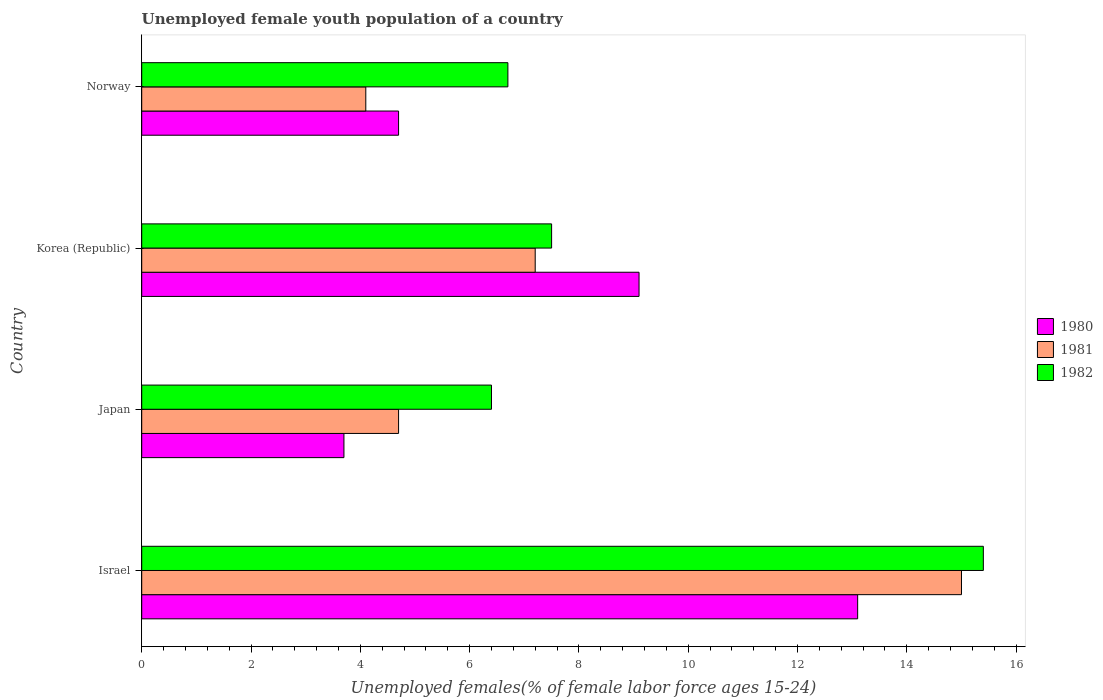How many different coloured bars are there?
Keep it short and to the point. 3. How many groups of bars are there?
Offer a very short reply. 4. Are the number of bars on each tick of the Y-axis equal?
Your answer should be very brief. Yes. How many bars are there on the 4th tick from the top?
Your answer should be very brief. 3. What is the label of the 4th group of bars from the top?
Give a very brief answer. Israel. What is the percentage of unemployed female youth population in 1981 in Israel?
Provide a succinct answer. 15. Across all countries, what is the maximum percentage of unemployed female youth population in 1982?
Your answer should be compact. 15.4. Across all countries, what is the minimum percentage of unemployed female youth population in 1981?
Give a very brief answer. 4.1. In which country was the percentage of unemployed female youth population in 1980 maximum?
Provide a succinct answer. Israel. What is the total percentage of unemployed female youth population in 1981 in the graph?
Your answer should be very brief. 31. What is the difference between the percentage of unemployed female youth population in 1981 in Korea (Republic) and that in Norway?
Offer a terse response. 3.1. What is the difference between the percentage of unemployed female youth population in 1982 in Israel and the percentage of unemployed female youth population in 1981 in Japan?
Your answer should be compact. 10.7. What is the average percentage of unemployed female youth population in 1982 per country?
Provide a succinct answer. 9. What is the difference between the percentage of unemployed female youth population in 1982 and percentage of unemployed female youth population in 1981 in Japan?
Ensure brevity in your answer.  1.7. In how many countries, is the percentage of unemployed female youth population in 1980 greater than 1.2000000000000002 %?
Provide a short and direct response. 4. What is the ratio of the percentage of unemployed female youth population in 1981 in Israel to that in Korea (Republic)?
Make the answer very short. 2.08. Is the percentage of unemployed female youth population in 1982 in Japan less than that in Korea (Republic)?
Provide a short and direct response. Yes. Is the difference between the percentage of unemployed female youth population in 1982 in Japan and Norway greater than the difference between the percentage of unemployed female youth population in 1981 in Japan and Norway?
Make the answer very short. No. What is the difference between the highest and the second highest percentage of unemployed female youth population in 1980?
Your answer should be very brief. 4. What is the difference between the highest and the lowest percentage of unemployed female youth population in 1981?
Provide a short and direct response. 10.9. In how many countries, is the percentage of unemployed female youth population in 1980 greater than the average percentage of unemployed female youth population in 1980 taken over all countries?
Ensure brevity in your answer.  2. Is the sum of the percentage of unemployed female youth population in 1982 in Israel and Korea (Republic) greater than the maximum percentage of unemployed female youth population in 1980 across all countries?
Your answer should be compact. Yes. Is it the case that in every country, the sum of the percentage of unemployed female youth population in 1980 and percentage of unemployed female youth population in 1982 is greater than the percentage of unemployed female youth population in 1981?
Offer a terse response. Yes. Are all the bars in the graph horizontal?
Provide a short and direct response. Yes. How many countries are there in the graph?
Offer a terse response. 4. Does the graph contain grids?
Offer a very short reply. No. Where does the legend appear in the graph?
Offer a terse response. Center right. How many legend labels are there?
Provide a succinct answer. 3. How are the legend labels stacked?
Give a very brief answer. Vertical. What is the title of the graph?
Your answer should be very brief. Unemployed female youth population of a country. What is the label or title of the X-axis?
Your answer should be compact. Unemployed females(% of female labor force ages 15-24). What is the Unemployed females(% of female labor force ages 15-24) in 1980 in Israel?
Your answer should be compact. 13.1. What is the Unemployed females(% of female labor force ages 15-24) of 1982 in Israel?
Offer a terse response. 15.4. What is the Unemployed females(% of female labor force ages 15-24) in 1980 in Japan?
Ensure brevity in your answer.  3.7. What is the Unemployed females(% of female labor force ages 15-24) of 1981 in Japan?
Keep it short and to the point. 4.7. What is the Unemployed females(% of female labor force ages 15-24) of 1982 in Japan?
Provide a short and direct response. 6.4. What is the Unemployed females(% of female labor force ages 15-24) in 1980 in Korea (Republic)?
Offer a very short reply. 9.1. What is the Unemployed females(% of female labor force ages 15-24) of 1981 in Korea (Republic)?
Your response must be concise. 7.2. What is the Unemployed females(% of female labor force ages 15-24) of 1980 in Norway?
Give a very brief answer. 4.7. What is the Unemployed females(% of female labor force ages 15-24) of 1981 in Norway?
Ensure brevity in your answer.  4.1. What is the Unemployed females(% of female labor force ages 15-24) in 1982 in Norway?
Ensure brevity in your answer.  6.7. Across all countries, what is the maximum Unemployed females(% of female labor force ages 15-24) of 1980?
Your response must be concise. 13.1. Across all countries, what is the maximum Unemployed females(% of female labor force ages 15-24) in 1981?
Give a very brief answer. 15. Across all countries, what is the maximum Unemployed females(% of female labor force ages 15-24) in 1982?
Provide a succinct answer. 15.4. Across all countries, what is the minimum Unemployed females(% of female labor force ages 15-24) of 1980?
Give a very brief answer. 3.7. Across all countries, what is the minimum Unemployed females(% of female labor force ages 15-24) of 1981?
Your response must be concise. 4.1. Across all countries, what is the minimum Unemployed females(% of female labor force ages 15-24) in 1982?
Provide a short and direct response. 6.4. What is the total Unemployed females(% of female labor force ages 15-24) in 1980 in the graph?
Ensure brevity in your answer.  30.6. What is the total Unemployed females(% of female labor force ages 15-24) of 1981 in the graph?
Provide a short and direct response. 31. What is the total Unemployed females(% of female labor force ages 15-24) in 1982 in the graph?
Offer a very short reply. 36. What is the difference between the Unemployed females(% of female labor force ages 15-24) in 1982 in Israel and that in Japan?
Your answer should be compact. 9. What is the difference between the Unemployed females(% of female labor force ages 15-24) in 1981 in Israel and that in Korea (Republic)?
Give a very brief answer. 7.8. What is the difference between the Unemployed females(% of female labor force ages 15-24) of 1980 in Israel and that in Norway?
Your answer should be compact. 8.4. What is the difference between the Unemployed females(% of female labor force ages 15-24) of 1981 in Israel and that in Norway?
Your answer should be very brief. 10.9. What is the difference between the Unemployed females(% of female labor force ages 15-24) in 1982 in Israel and that in Norway?
Provide a short and direct response. 8.7. What is the difference between the Unemployed females(% of female labor force ages 15-24) in 1980 in Japan and that in Korea (Republic)?
Offer a terse response. -5.4. What is the difference between the Unemployed females(% of female labor force ages 15-24) in 1980 in Japan and that in Norway?
Your response must be concise. -1. What is the difference between the Unemployed females(% of female labor force ages 15-24) of 1981 in Japan and that in Norway?
Provide a succinct answer. 0.6. What is the difference between the Unemployed females(% of female labor force ages 15-24) of 1980 in Korea (Republic) and that in Norway?
Ensure brevity in your answer.  4.4. What is the difference between the Unemployed females(% of female labor force ages 15-24) of 1981 in Korea (Republic) and that in Norway?
Your answer should be very brief. 3.1. What is the difference between the Unemployed females(% of female labor force ages 15-24) of 1982 in Korea (Republic) and that in Norway?
Offer a very short reply. 0.8. What is the difference between the Unemployed females(% of female labor force ages 15-24) in 1980 in Israel and the Unemployed females(% of female labor force ages 15-24) in 1982 in Japan?
Make the answer very short. 6.7. What is the difference between the Unemployed females(% of female labor force ages 15-24) of 1980 in Israel and the Unemployed females(% of female labor force ages 15-24) of 1981 in Korea (Republic)?
Offer a terse response. 5.9. What is the difference between the Unemployed females(% of female labor force ages 15-24) in 1980 in Israel and the Unemployed females(% of female labor force ages 15-24) in 1982 in Norway?
Provide a succinct answer. 6.4. What is the difference between the Unemployed females(% of female labor force ages 15-24) in 1980 in Japan and the Unemployed females(% of female labor force ages 15-24) in 1981 in Korea (Republic)?
Make the answer very short. -3.5. What is the difference between the Unemployed females(% of female labor force ages 15-24) of 1980 in Japan and the Unemployed females(% of female labor force ages 15-24) of 1982 in Norway?
Offer a terse response. -3. What is the difference between the Unemployed females(% of female labor force ages 15-24) in 1981 in Japan and the Unemployed females(% of female labor force ages 15-24) in 1982 in Norway?
Your response must be concise. -2. What is the difference between the Unemployed females(% of female labor force ages 15-24) in 1981 in Korea (Republic) and the Unemployed females(% of female labor force ages 15-24) in 1982 in Norway?
Your answer should be compact. 0.5. What is the average Unemployed females(% of female labor force ages 15-24) in 1980 per country?
Ensure brevity in your answer.  7.65. What is the average Unemployed females(% of female labor force ages 15-24) of 1981 per country?
Offer a very short reply. 7.75. What is the average Unemployed females(% of female labor force ages 15-24) of 1982 per country?
Your answer should be compact. 9. What is the difference between the Unemployed females(% of female labor force ages 15-24) in 1981 and Unemployed females(% of female labor force ages 15-24) in 1982 in Korea (Republic)?
Provide a succinct answer. -0.3. What is the ratio of the Unemployed females(% of female labor force ages 15-24) in 1980 in Israel to that in Japan?
Your answer should be very brief. 3.54. What is the ratio of the Unemployed females(% of female labor force ages 15-24) of 1981 in Israel to that in Japan?
Give a very brief answer. 3.19. What is the ratio of the Unemployed females(% of female labor force ages 15-24) in 1982 in Israel to that in Japan?
Your answer should be compact. 2.41. What is the ratio of the Unemployed females(% of female labor force ages 15-24) of 1980 in Israel to that in Korea (Republic)?
Give a very brief answer. 1.44. What is the ratio of the Unemployed females(% of female labor force ages 15-24) of 1981 in Israel to that in Korea (Republic)?
Your answer should be compact. 2.08. What is the ratio of the Unemployed females(% of female labor force ages 15-24) of 1982 in Israel to that in Korea (Republic)?
Make the answer very short. 2.05. What is the ratio of the Unemployed females(% of female labor force ages 15-24) of 1980 in Israel to that in Norway?
Make the answer very short. 2.79. What is the ratio of the Unemployed females(% of female labor force ages 15-24) in 1981 in Israel to that in Norway?
Your answer should be compact. 3.66. What is the ratio of the Unemployed females(% of female labor force ages 15-24) of 1982 in Israel to that in Norway?
Your answer should be compact. 2.3. What is the ratio of the Unemployed females(% of female labor force ages 15-24) of 1980 in Japan to that in Korea (Republic)?
Keep it short and to the point. 0.41. What is the ratio of the Unemployed females(% of female labor force ages 15-24) in 1981 in Japan to that in Korea (Republic)?
Ensure brevity in your answer.  0.65. What is the ratio of the Unemployed females(% of female labor force ages 15-24) of 1982 in Japan to that in Korea (Republic)?
Make the answer very short. 0.85. What is the ratio of the Unemployed females(% of female labor force ages 15-24) of 1980 in Japan to that in Norway?
Your answer should be compact. 0.79. What is the ratio of the Unemployed females(% of female labor force ages 15-24) of 1981 in Japan to that in Norway?
Ensure brevity in your answer.  1.15. What is the ratio of the Unemployed females(% of female labor force ages 15-24) in 1982 in Japan to that in Norway?
Keep it short and to the point. 0.96. What is the ratio of the Unemployed females(% of female labor force ages 15-24) in 1980 in Korea (Republic) to that in Norway?
Keep it short and to the point. 1.94. What is the ratio of the Unemployed females(% of female labor force ages 15-24) of 1981 in Korea (Republic) to that in Norway?
Keep it short and to the point. 1.76. What is the ratio of the Unemployed females(% of female labor force ages 15-24) in 1982 in Korea (Republic) to that in Norway?
Make the answer very short. 1.12. What is the difference between the highest and the second highest Unemployed females(% of female labor force ages 15-24) in 1980?
Provide a succinct answer. 4. What is the difference between the highest and the second highest Unemployed females(% of female labor force ages 15-24) in 1982?
Offer a terse response. 7.9. 